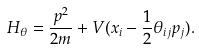Convert formula to latex. <formula><loc_0><loc_0><loc_500><loc_500>H _ { \theta } = \frac { p ^ { 2 } } { 2 m } + V ( x _ { i } - \frac { 1 } { 2 } \theta _ { i j } p _ { j } ) .</formula> 